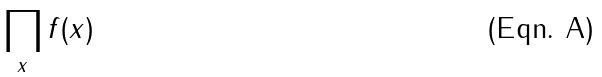Convert formula to latex. <formula><loc_0><loc_0><loc_500><loc_500>\prod _ { x } f ( x )</formula> 